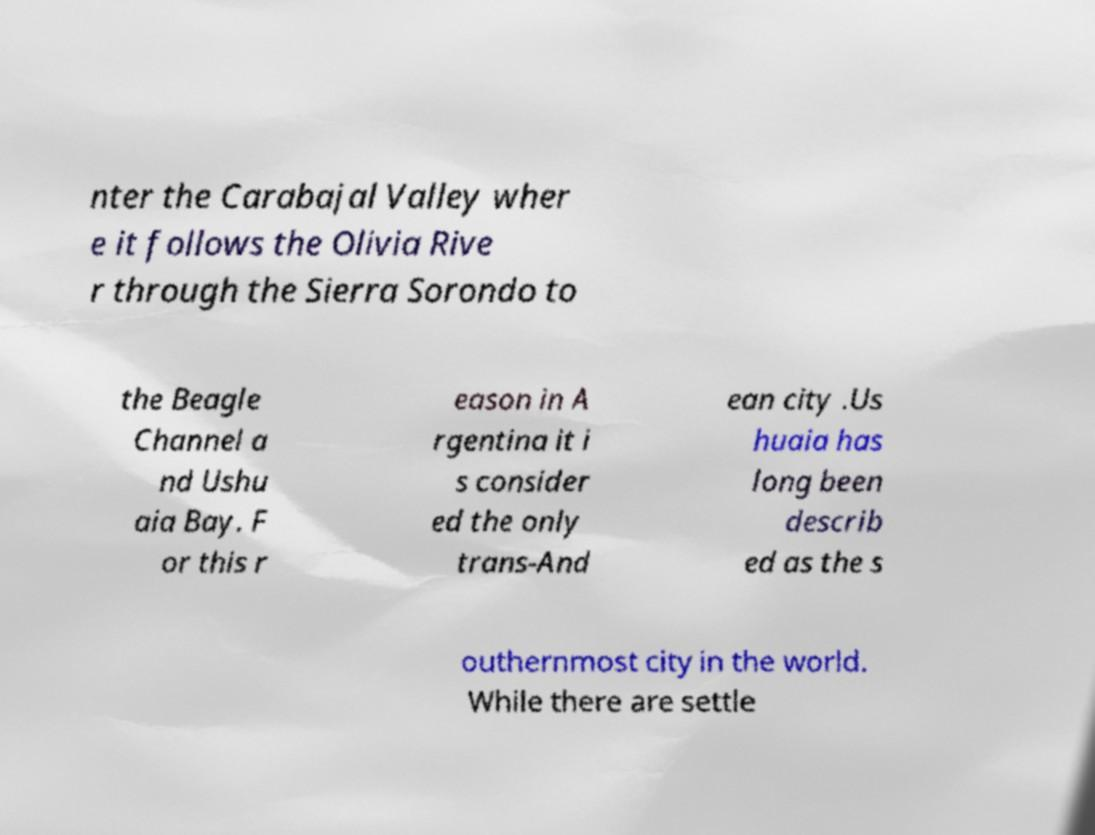Could you extract and type out the text from this image? nter the Carabajal Valley wher e it follows the Olivia Rive r through the Sierra Sorondo to the Beagle Channel a nd Ushu aia Bay. F or this r eason in A rgentina it i s consider ed the only trans-And ean city .Us huaia has long been describ ed as the s outhernmost city in the world. While there are settle 